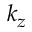Convert formula to latex. <formula><loc_0><loc_0><loc_500><loc_500>k _ { z }</formula> 